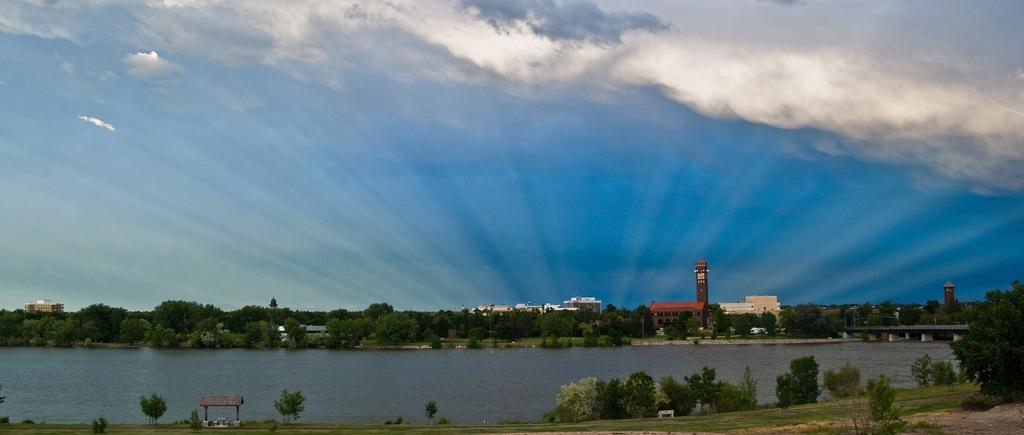How would you summarize this image in a sentence or two? At the bottom of the image we can see some trees, grass and water. In the middle of the image we can see some trees and buildings. At the top of the image we can see some clouds in the sky. 